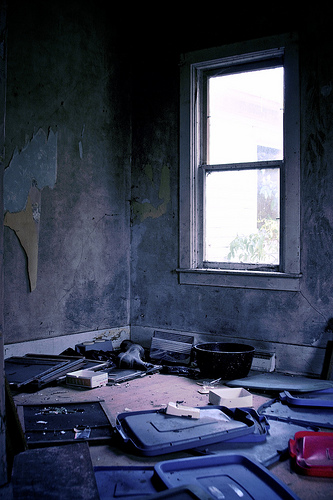<image>
Can you confirm if the lid is under the lid? No. The lid is not positioned under the lid. The vertical relationship between these objects is different. 